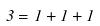<formula> <loc_0><loc_0><loc_500><loc_500>3 = 1 + 1 + 1</formula> 